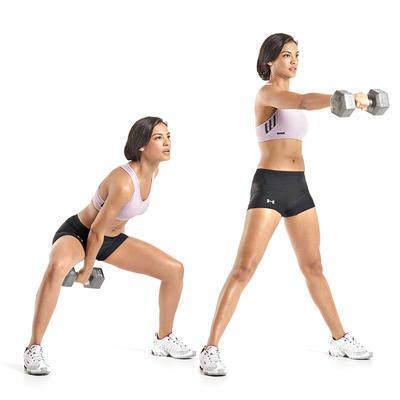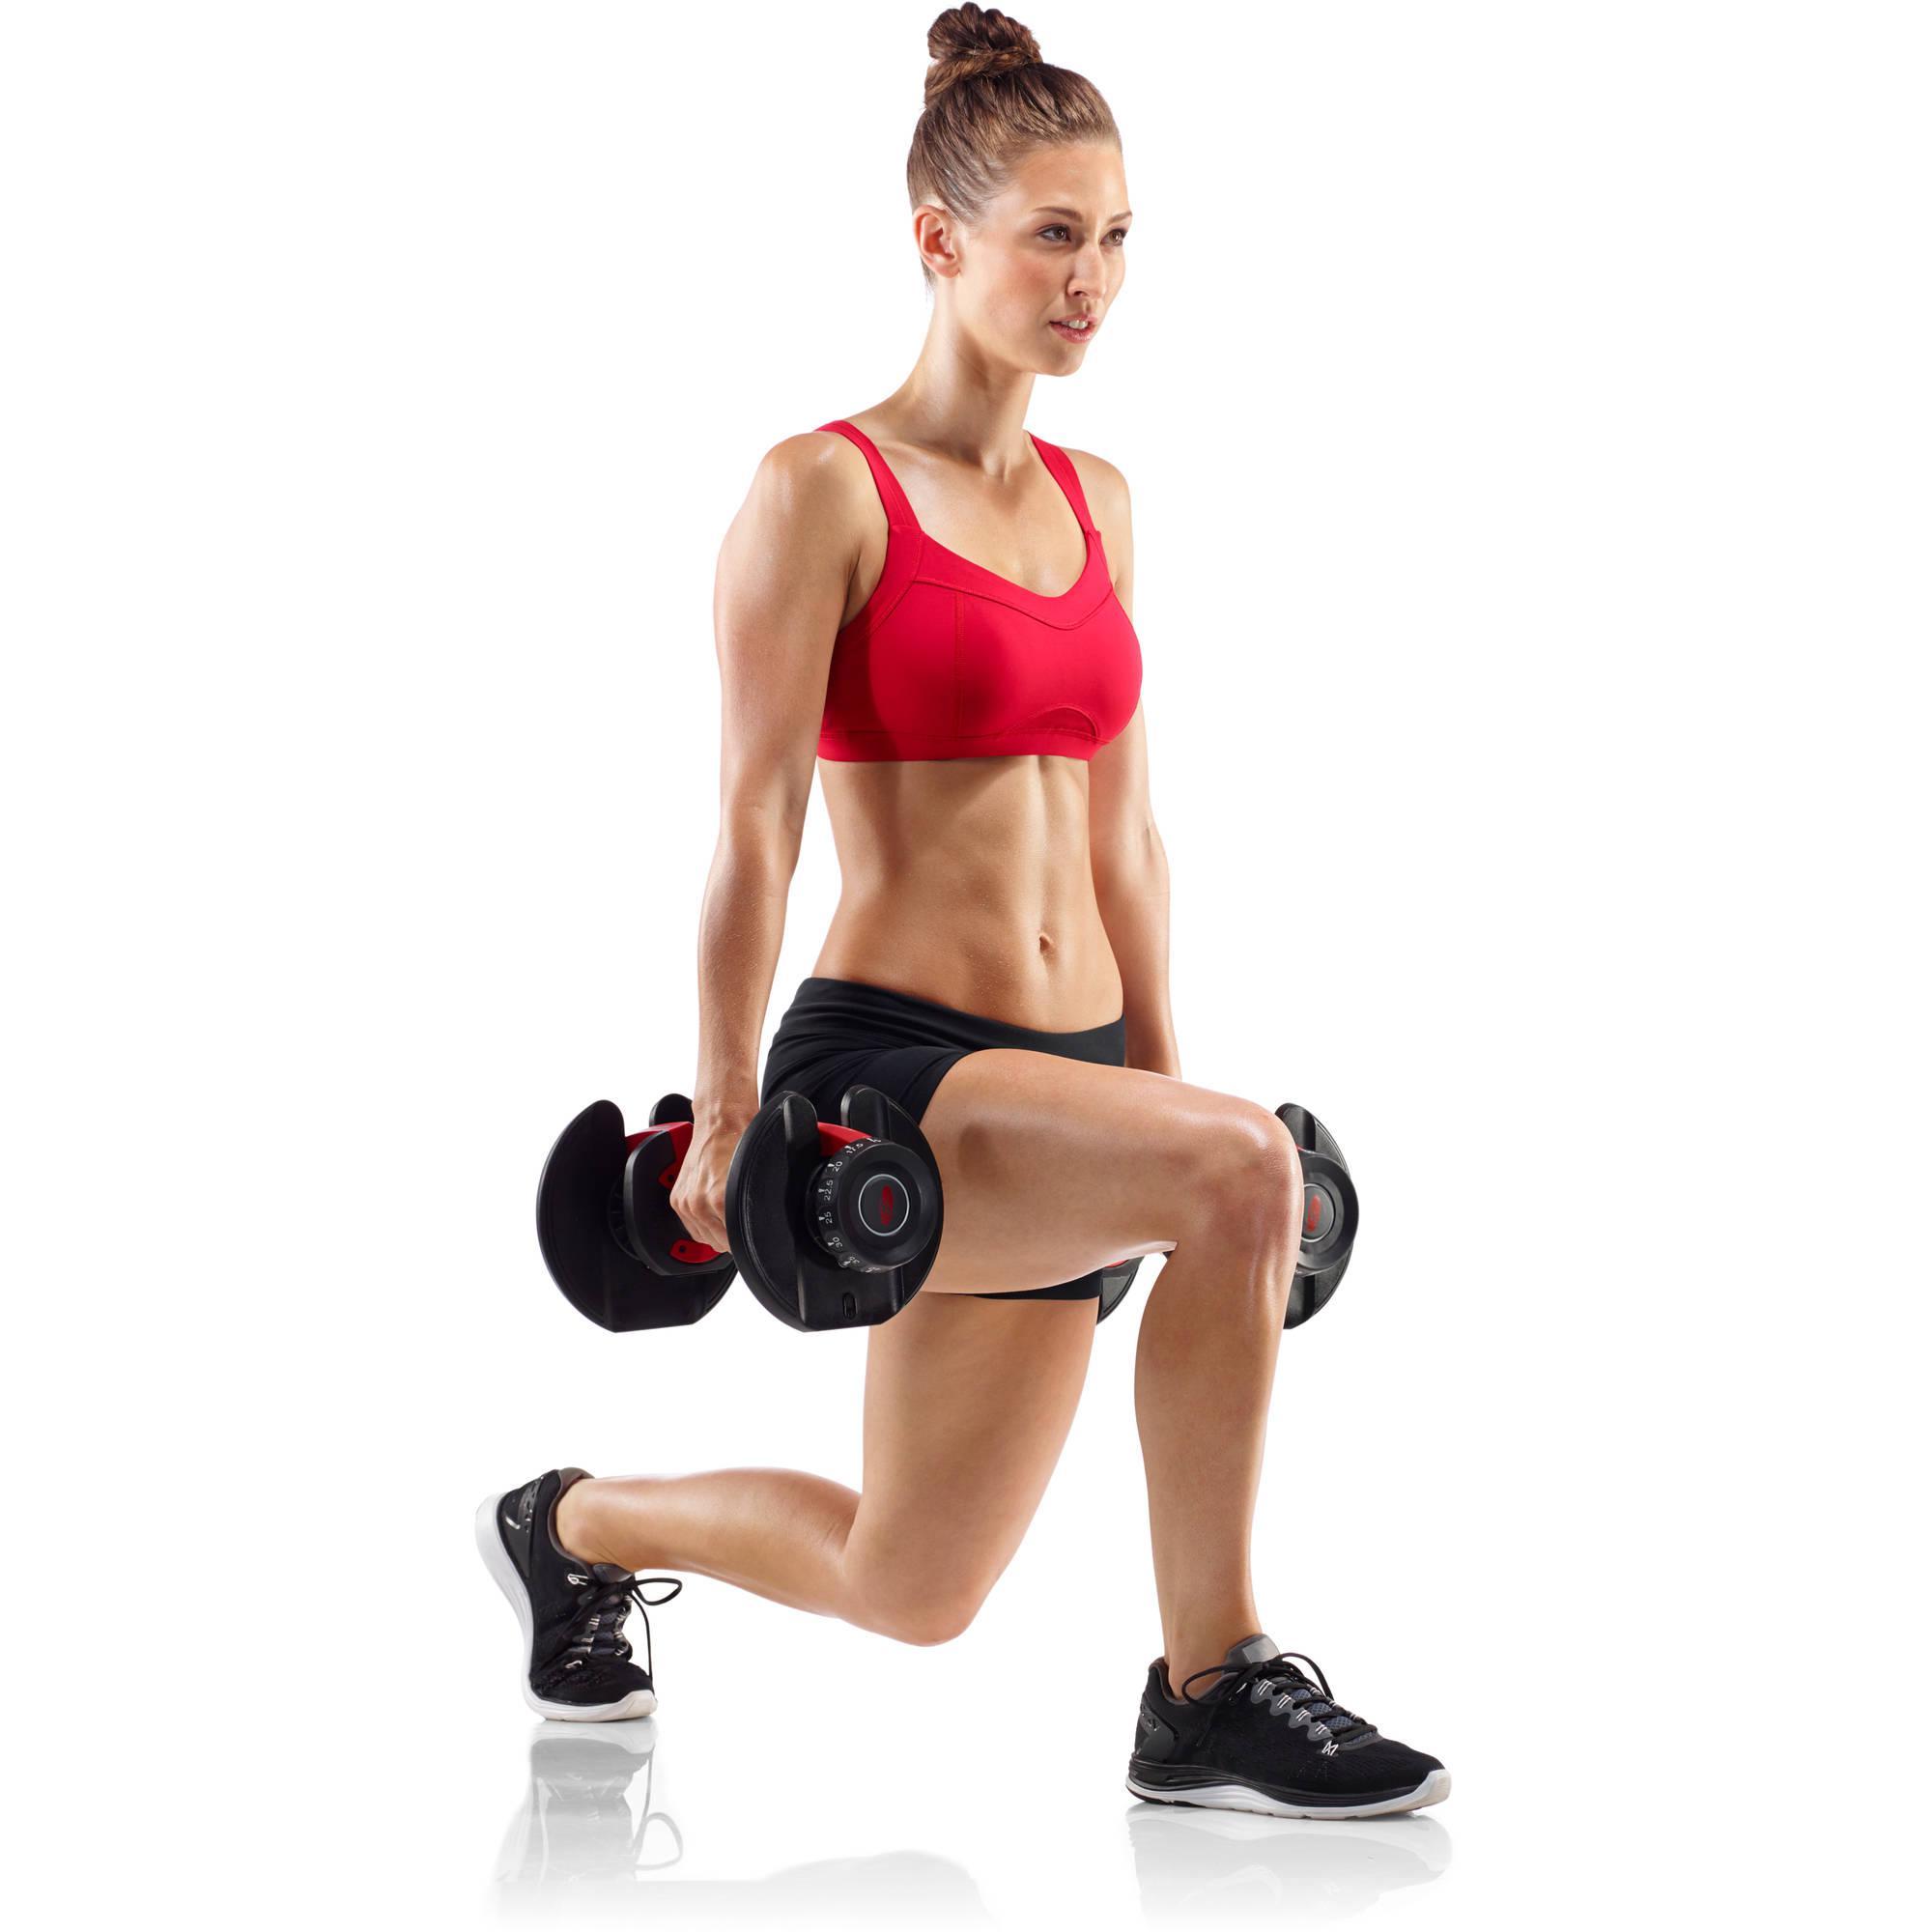The first image is the image on the left, the second image is the image on the right. For the images shown, is this caption "One of the images contains a woman sitting on fitness equipment." true? Answer yes or no. No. 